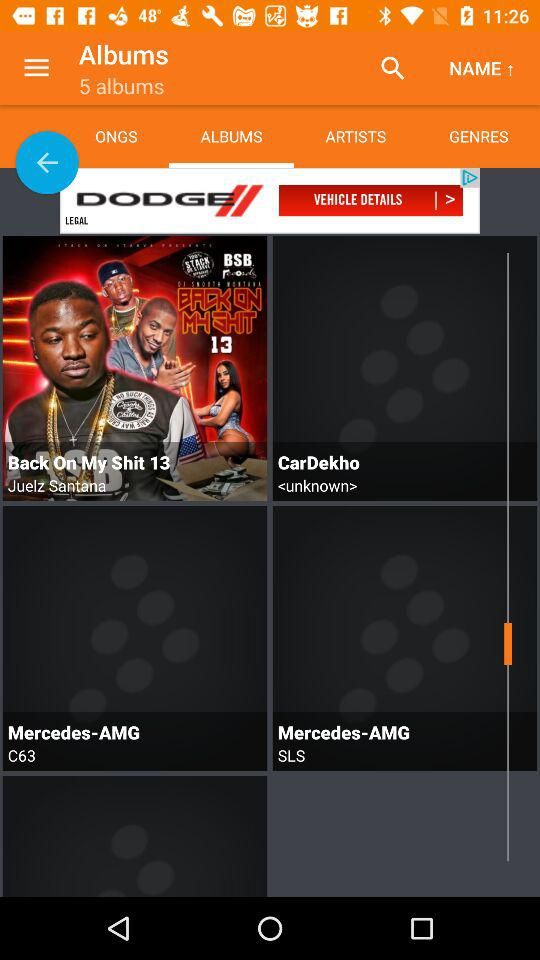Which album is composed by "C63"? The album composed by "C63" is "Mercedes-AMG". 